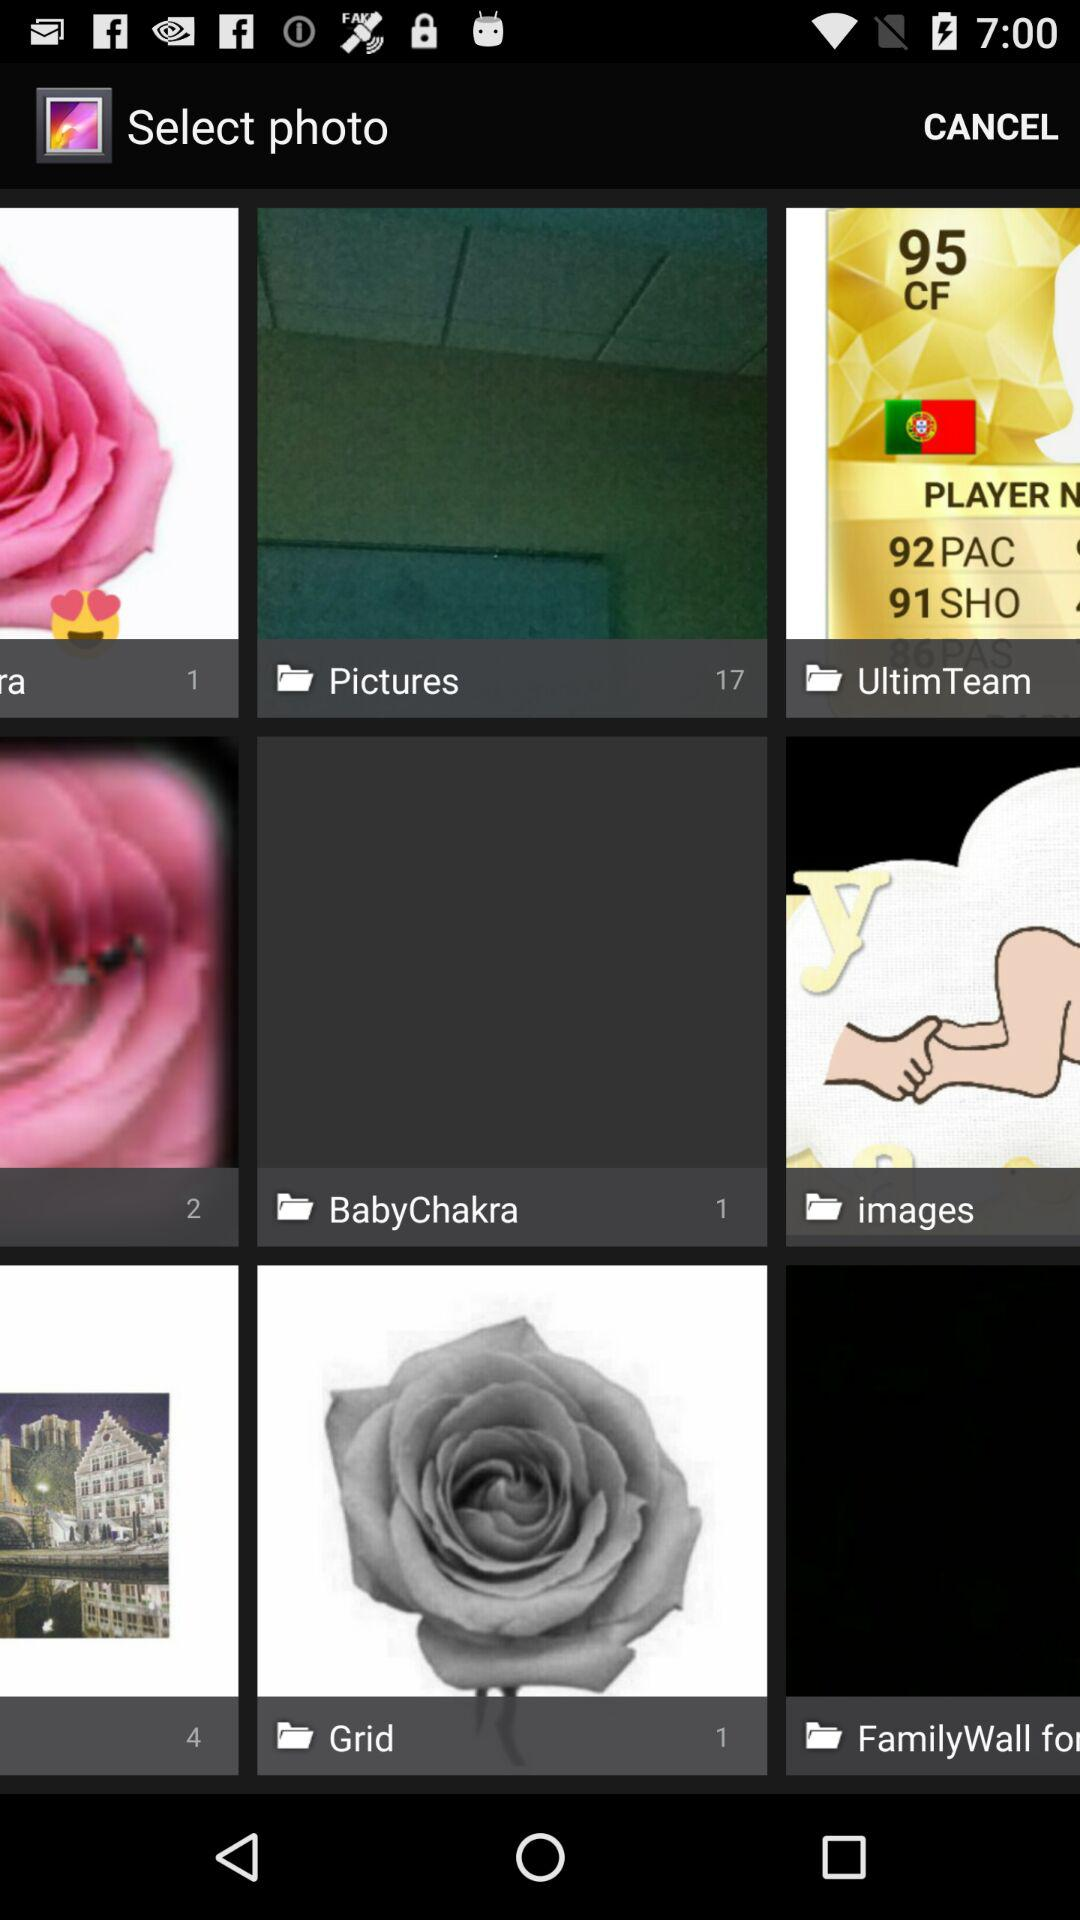How many pictures are in the "Pictures" folder? There are 17 pictures. 